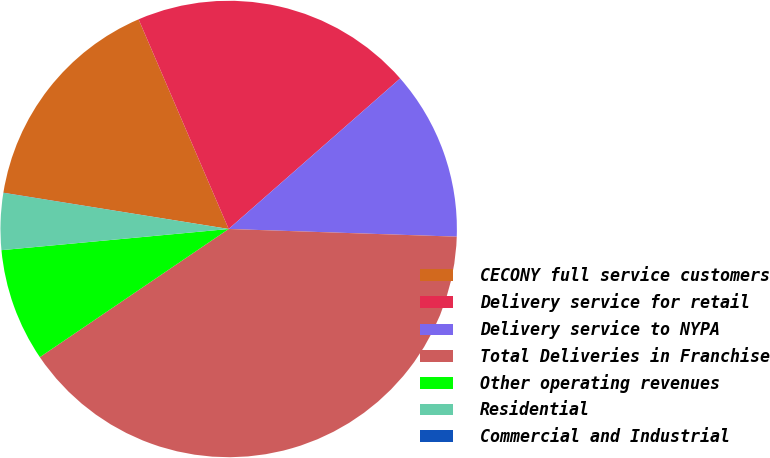Convert chart to OTSL. <chart><loc_0><loc_0><loc_500><loc_500><pie_chart><fcel>CECONY full service customers<fcel>Delivery service for retail<fcel>Delivery service to NYPA<fcel>Total Deliveries in Franchise<fcel>Other operating revenues<fcel>Residential<fcel>Commercial and Industrial<nl><fcel>16.0%<fcel>19.99%<fcel>12.0%<fcel>39.97%<fcel>8.01%<fcel>4.01%<fcel>0.01%<nl></chart> 